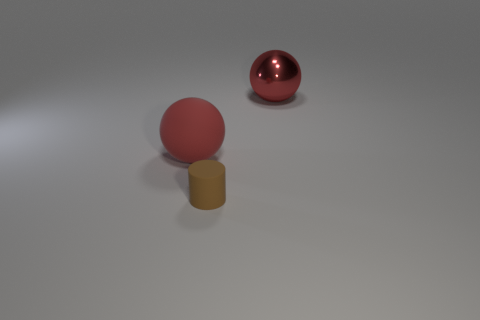What shape is the small object?
Give a very brief answer. Cylinder. There is another red thing that is the same size as the red metallic thing; what is it made of?
Provide a short and direct response. Rubber. Is there anything else that is the same size as the red matte sphere?
Provide a succinct answer. Yes. How many things are brown cubes or big spheres that are behind the large red matte sphere?
Your answer should be very brief. 1. What size is the red sphere that is made of the same material as the cylinder?
Offer a terse response. Large. There is a brown object left of the large ball that is on the right side of the red rubber sphere; what shape is it?
Your answer should be very brief. Cylinder. What is the size of the thing that is both behind the cylinder and on the right side of the large rubber ball?
Your answer should be very brief. Large. Are there any tiny blue objects that have the same shape as the small brown thing?
Give a very brief answer. No. Are there any other things that have the same shape as the red shiny thing?
Your answer should be compact. Yes. What material is the red sphere that is in front of the large red sphere that is behind the big object that is in front of the big metallic ball made of?
Offer a very short reply. Rubber. 